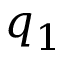Convert formula to latex. <formula><loc_0><loc_0><loc_500><loc_500>q _ { 1 }</formula> 